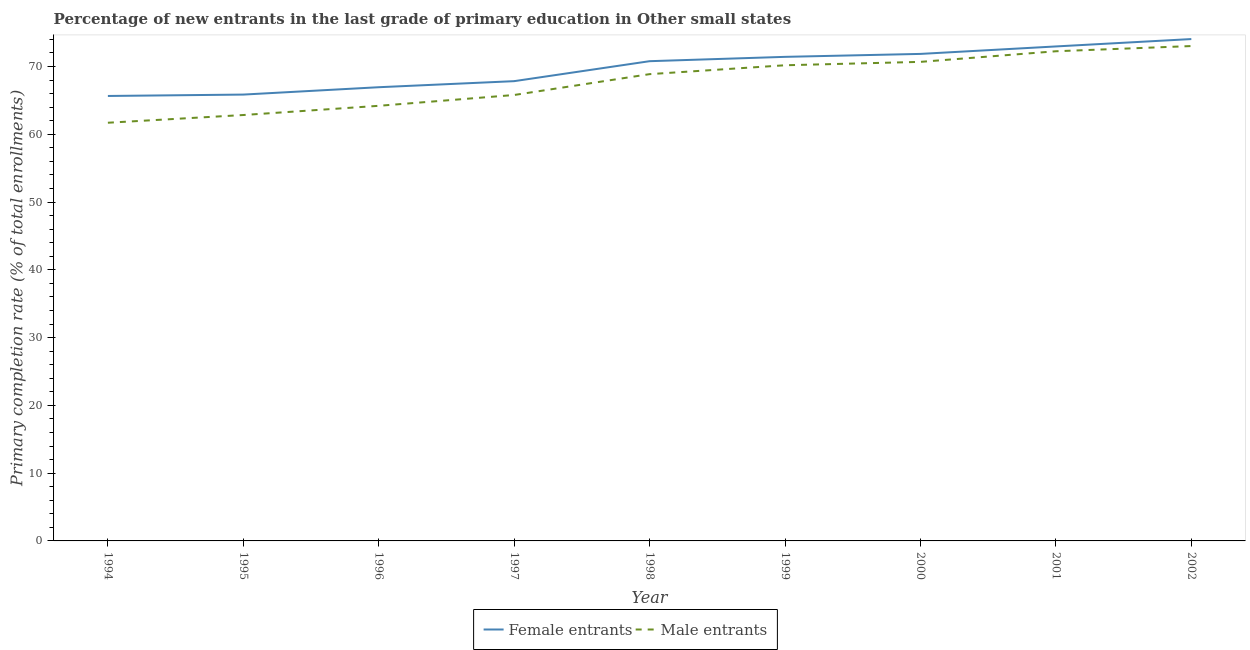How many different coloured lines are there?
Your answer should be compact. 2. Does the line corresponding to primary completion rate of male entrants intersect with the line corresponding to primary completion rate of female entrants?
Give a very brief answer. No. What is the primary completion rate of male entrants in 1995?
Give a very brief answer. 62.84. Across all years, what is the maximum primary completion rate of male entrants?
Provide a short and direct response. 73.02. Across all years, what is the minimum primary completion rate of male entrants?
Provide a succinct answer. 61.7. In which year was the primary completion rate of male entrants minimum?
Your response must be concise. 1994. What is the total primary completion rate of male entrants in the graph?
Offer a very short reply. 609.54. What is the difference between the primary completion rate of female entrants in 1996 and that in 1998?
Make the answer very short. -3.84. What is the difference between the primary completion rate of male entrants in 1999 and the primary completion rate of female entrants in 2001?
Your answer should be compact. -2.78. What is the average primary completion rate of female entrants per year?
Ensure brevity in your answer.  69.71. In the year 1998, what is the difference between the primary completion rate of female entrants and primary completion rate of male entrants?
Offer a very short reply. 1.91. In how many years, is the primary completion rate of male entrants greater than 56 %?
Your response must be concise. 9. What is the ratio of the primary completion rate of female entrants in 1997 to that in 1999?
Offer a very short reply. 0.95. What is the difference between the highest and the second highest primary completion rate of female entrants?
Offer a very short reply. 1.09. What is the difference between the highest and the lowest primary completion rate of male entrants?
Give a very brief answer. 11.32. Does the primary completion rate of male entrants monotonically increase over the years?
Your answer should be compact. Yes. Is the primary completion rate of male entrants strictly greater than the primary completion rate of female entrants over the years?
Provide a succinct answer. No. How many lines are there?
Ensure brevity in your answer.  2. What is the difference between two consecutive major ticks on the Y-axis?
Provide a short and direct response. 10. Does the graph contain any zero values?
Keep it short and to the point. No. How many legend labels are there?
Your answer should be compact. 2. How are the legend labels stacked?
Ensure brevity in your answer.  Horizontal. What is the title of the graph?
Your answer should be very brief. Percentage of new entrants in the last grade of primary education in Other small states. What is the label or title of the X-axis?
Ensure brevity in your answer.  Year. What is the label or title of the Y-axis?
Your answer should be compact. Primary completion rate (% of total enrollments). What is the Primary completion rate (% of total enrollments) in Female entrants in 1994?
Provide a short and direct response. 65.65. What is the Primary completion rate (% of total enrollments) in Male entrants in 1994?
Give a very brief answer. 61.7. What is the Primary completion rate (% of total enrollments) in Female entrants in 1995?
Provide a short and direct response. 65.86. What is the Primary completion rate (% of total enrollments) of Male entrants in 1995?
Provide a succinct answer. 62.84. What is the Primary completion rate (% of total enrollments) of Female entrants in 1996?
Provide a short and direct response. 66.94. What is the Primary completion rate (% of total enrollments) of Male entrants in 1996?
Make the answer very short. 64.2. What is the Primary completion rate (% of total enrollments) of Female entrants in 1997?
Offer a very short reply. 67.84. What is the Primary completion rate (% of total enrollments) of Male entrants in 1997?
Provide a succinct answer. 65.8. What is the Primary completion rate (% of total enrollments) of Female entrants in 1998?
Offer a terse response. 70.78. What is the Primary completion rate (% of total enrollments) of Male entrants in 1998?
Your response must be concise. 68.87. What is the Primary completion rate (% of total enrollments) in Female entrants in 1999?
Your response must be concise. 71.42. What is the Primary completion rate (% of total enrollments) of Male entrants in 1999?
Your answer should be compact. 70.18. What is the Primary completion rate (% of total enrollments) in Female entrants in 2000?
Keep it short and to the point. 71.86. What is the Primary completion rate (% of total enrollments) in Male entrants in 2000?
Your answer should be compact. 70.68. What is the Primary completion rate (% of total enrollments) in Female entrants in 2001?
Offer a very short reply. 72.96. What is the Primary completion rate (% of total enrollments) of Male entrants in 2001?
Give a very brief answer. 72.25. What is the Primary completion rate (% of total enrollments) of Female entrants in 2002?
Give a very brief answer. 74.05. What is the Primary completion rate (% of total enrollments) in Male entrants in 2002?
Provide a short and direct response. 73.02. Across all years, what is the maximum Primary completion rate (% of total enrollments) of Female entrants?
Ensure brevity in your answer.  74.05. Across all years, what is the maximum Primary completion rate (% of total enrollments) in Male entrants?
Make the answer very short. 73.02. Across all years, what is the minimum Primary completion rate (% of total enrollments) of Female entrants?
Give a very brief answer. 65.65. Across all years, what is the minimum Primary completion rate (% of total enrollments) of Male entrants?
Offer a very short reply. 61.7. What is the total Primary completion rate (% of total enrollments) in Female entrants in the graph?
Provide a succinct answer. 627.36. What is the total Primary completion rate (% of total enrollments) in Male entrants in the graph?
Make the answer very short. 609.54. What is the difference between the Primary completion rate (% of total enrollments) in Female entrants in 1994 and that in 1995?
Provide a short and direct response. -0.2. What is the difference between the Primary completion rate (% of total enrollments) in Male entrants in 1994 and that in 1995?
Your response must be concise. -1.14. What is the difference between the Primary completion rate (% of total enrollments) of Female entrants in 1994 and that in 1996?
Keep it short and to the point. -1.29. What is the difference between the Primary completion rate (% of total enrollments) in Male entrants in 1994 and that in 1996?
Your answer should be very brief. -2.5. What is the difference between the Primary completion rate (% of total enrollments) in Female entrants in 1994 and that in 1997?
Make the answer very short. -2.18. What is the difference between the Primary completion rate (% of total enrollments) in Male entrants in 1994 and that in 1997?
Your response must be concise. -4.09. What is the difference between the Primary completion rate (% of total enrollments) in Female entrants in 1994 and that in 1998?
Your answer should be compact. -5.13. What is the difference between the Primary completion rate (% of total enrollments) of Male entrants in 1994 and that in 1998?
Ensure brevity in your answer.  -7.17. What is the difference between the Primary completion rate (% of total enrollments) in Female entrants in 1994 and that in 1999?
Ensure brevity in your answer.  -5.77. What is the difference between the Primary completion rate (% of total enrollments) in Male entrants in 1994 and that in 1999?
Provide a succinct answer. -8.48. What is the difference between the Primary completion rate (% of total enrollments) in Female entrants in 1994 and that in 2000?
Keep it short and to the point. -6.21. What is the difference between the Primary completion rate (% of total enrollments) in Male entrants in 1994 and that in 2000?
Provide a short and direct response. -8.98. What is the difference between the Primary completion rate (% of total enrollments) of Female entrants in 1994 and that in 2001?
Ensure brevity in your answer.  -7.31. What is the difference between the Primary completion rate (% of total enrollments) of Male entrants in 1994 and that in 2001?
Offer a very short reply. -10.55. What is the difference between the Primary completion rate (% of total enrollments) in Female entrants in 1994 and that in 2002?
Make the answer very short. -8.4. What is the difference between the Primary completion rate (% of total enrollments) of Male entrants in 1994 and that in 2002?
Give a very brief answer. -11.32. What is the difference between the Primary completion rate (% of total enrollments) of Female entrants in 1995 and that in 1996?
Offer a terse response. -1.09. What is the difference between the Primary completion rate (% of total enrollments) of Male entrants in 1995 and that in 1996?
Keep it short and to the point. -1.36. What is the difference between the Primary completion rate (% of total enrollments) of Female entrants in 1995 and that in 1997?
Your response must be concise. -1.98. What is the difference between the Primary completion rate (% of total enrollments) of Male entrants in 1995 and that in 1997?
Provide a succinct answer. -2.96. What is the difference between the Primary completion rate (% of total enrollments) of Female entrants in 1995 and that in 1998?
Your answer should be compact. -4.93. What is the difference between the Primary completion rate (% of total enrollments) in Male entrants in 1995 and that in 1998?
Offer a terse response. -6.03. What is the difference between the Primary completion rate (% of total enrollments) of Female entrants in 1995 and that in 1999?
Keep it short and to the point. -5.57. What is the difference between the Primary completion rate (% of total enrollments) in Male entrants in 1995 and that in 1999?
Make the answer very short. -7.34. What is the difference between the Primary completion rate (% of total enrollments) of Female entrants in 1995 and that in 2000?
Provide a short and direct response. -6. What is the difference between the Primary completion rate (% of total enrollments) of Male entrants in 1995 and that in 2000?
Offer a very short reply. -7.84. What is the difference between the Primary completion rate (% of total enrollments) in Female entrants in 1995 and that in 2001?
Offer a very short reply. -7.1. What is the difference between the Primary completion rate (% of total enrollments) in Male entrants in 1995 and that in 2001?
Your answer should be very brief. -9.41. What is the difference between the Primary completion rate (% of total enrollments) in Female entrants in 1995 and that in 2002?
Keep it short and to the point. -8.19. What is the difference between the Primary completion rate (% of total enrollments) of Male entrants in 1995 and that in 2002?
Keep it short and to the point. -10.18. What is the difference between the Primary completion rate (% of total enrollments) of Female entrants in 1996 and that in 1997?
Offer a terse response. -0.89. What is the difference between the Primary completion rate (% of total enrollments) of Male entrants in 1996 and that in 1997?
Make the answer very short. -1.6. What is the difference between the Primary completion rate (% of total enrollments) in Female entrants in 1996 and that in 1998?
Your answer should be compact. -3.84. What is the difference between the Primary completion rate (% of total enrollments) in Male entrants in 1996 and that in 1998?
Give a very brief answer. -4.67. What is the difference between the Primary completion rate (% of total enrollments) of Female entrants in 1996 and that in 1999?
Give a very brief answer. -4.48. What is the difference between the Primary completion rate (% of total enrollments) of Male entrants in 1996 and that in 1999?
Your answer should be compact. -5.98. What is the difference between the Primary completion rate (% of total enrollments) in Female entrants in 1996 and that in 2000?
Offer a terse response. -4.91. What is the difference between the Primary completion rate (% of total enrollments) of Male entrants in 1996 and that in 2000?
Offer a terse response. -6.48. What is the difference between the Primary completion rate (% of total enrollments) of Female entrants in 1996 and that in 2001?
Keep it short and to the point. -6.02. What is the difference between the Primary completion rate (% of total enrollments) of Male entrants in 1996 and that in 2001?
Provide a succinct answer. -8.05. What is the difference between the Primary completion rate (% of total enrollments) of Female entrants in 1996 and that in 2002?
Ensure brevity in your answer.  -7.11. What is the difference between the Primary completion rate (% of total enrollments) in Male entrants in 1996 and that in 2002?
Your answer should be very brief. -8.82. What is the difference between the Primary completion rate (% of total enrollments) of Female entrants in 1997 and that in 1998?
Your answer should be very brief. -2.95. What is the difference between the Primary completion rate (% of total enrollments) in Male entrants in 1997 and that in 1998?
Your answer should be compact. -3.08. What is the difference between the Primary completion rate (% of total enrollments) of Female entrants in 1997 and that in 1999?
Provide a succinct answer. -3.59. What is the difference between the Primary completion rate (% of total enrollments) of Male entrants in 1997 and that in 1999?
Provide a succinct answer. -4.39. What is the difference between the Primary completion rate (% of total enrollments) of Female entrants in 1997 and that in 2000?
Your answer should be very brief. -4.02. What is the difference between the Primary completion rate (% of total enrollments) in Male entrants in 1997 and that in 2000?
Offer a very short reply. -4.89. What is the difference between the Primary completion rate (% of total enrollments) in Female entrants in 1997 and that in 2001?
Provide a succinct answer. -5.12. What is the difference between the Primary completion rate (% of total enrollments) of Male entrants in 1997 and that in 2001?
Make the answer very short. -6.45. What is the difference between the Primary completion rate (% of total enrollments) of Female entrants in 1997 and that in 2002?
Provide a short and direct response. -6.21. What is the difference between the Primary completion rate (% of total enrollments) of Male entrants in 1997 and that in 2002?
Keep it short and to the point. -7.22. What is the difference between the Primary completion rate (% of total enrollments) in Female entrants in 1998 and that in 1999?
Your answer should be compact. -0.64. What is the difference between the Primary completion rate (% of total enrollments) of Male entrants in 1998 and that in 1999?
Offer a very short reply. -1.31. What is the difference between the Primary completion rate (% of total enrollments) in Female entrants in 1998 and that in 2000?
Offer a very short reply. -1.07. What is the difference between the Primary completion rate (% of total enrollments) of Male entrants in 1998 and that in 2000?
Keep it short and to the point. -1.81. What is the difference between the Primary completion rate (% of total enrollments) of Female entrants in 1998 and that in 2001?
Offer a terse response. -2.18. What is the difference between the Primary completion rate (% of total enrollments) of Male entrants in 1998 and that in 2001?
Make the answer very short. -3.38. What is the difference between the Primary completion rate (% of total enrollments) in Female entrants in 1998 and that in 2002?
Provide a short and direct response. -3.26. What is the difference between the Primary completion rate (% of total enrollments) of Male entrants in 1998 and that in 2002?
Offer a very short reply. -4.15. What is the difference between the Primary completion rate (% of total enrollments) in Female entrants in 1999 and that in 2000?
Give a very brief answer. -0.43. What is the difference between the Primary completion rate (% of total enrollments) in Male entrants in 1999 and that in 2000?
Your answer should be very brief. -0.5. What is the difference between the Primary completion rate (% of total enrollments) in Female entrants in 1999 and that in 2001?
Provide a short and direct response. -1.54. What is the difference between the Primary completion rate (% of total enrollments) of Male entrants in 1999 and that in 2001?
Your response must be concise. -2.07. What is the difference between the Primary completion rate (% of total enrollments) in Female entrants in 1999 and that in 2002?
Your response must be concise. -2.63. What is the difference between the Primary completion rate (% of total enrollments) in Male entrants in 1999 and that in 2002?
Make the answer very short. -2.83. What is the difference between the Primary completion rate (% of total enrollments) of Female entrants in 2000 and that in 2001?
Give a very brief answer. -1.1. What is the difference between the Primary completion rate (% of total enrollments) in Male entrants in 2000 and that in 2001?
Your answer should be compact. -1.57. What is the difference between the Primary completion rate (% of total enrollments) of Female entrants in 2000 and that in 2002?
Your response must be concise. -2.19. What is the difference between the Primary completion rate (% of total enrollments) in Male entrants in 2000 and that in 2002?
Offer a terse response. -2.33. What is the difference between the Primary completion rate (% of total enrollments) in Female entrants in 2001 and that in 2002?
Your answer should be very brief. -1.09. What is the difference between the Primary completion rate (% of total enrollments) in Male entrants in 2001 and that in 2002?
Provide a succinct answer. -0.77. What is the difference between the Primary completion rate (% of total enrollments) in Female entrants in 1994 and the Primary completion rate (% of total enrollments) in Male entrants in 1995?
Your answer should be compact. 2.81. What is the difference between the Primary completion rate (% of total enrollments) in Female entrants in 1994 and the Primary completion rate (% of total enrollments) in Male entrants in 1996?
Give a very brief answer. 1.45. What is the difference between the Primary completion rate (% of total enrollments) of Female entrants in 1994 and the Primary completion rate (% of total enrollments) of Male entrants in 1997?
Your answer should be very brief. -0.14. What is the difference between the Primary completion rate (% of total enrollments) in Female entrants in 1994 and the Primary completion rate (% of total enrollments) in Male entrants in 1998?
Give a very brief answer. -3.22. What is the difference between the Primary completion rate (% of total enrollments) of Female entrants in 1994 and the Primary completion rate (% of total enrollments) of Male entrants in 1999?
Ensure brevity in your answer.  -4.53. What is the difference between the Primary completion rate (% of total enrollments) in Female entrants in 1994 and the Primary completion rate (% of total enrollments) in Male entrants in 2000?
Your answer should be compact. -5.03. What is the difference between the Primary completion rate (% of total enrollments) in Female entrants in 1994 and the Primary completion rate (% of total enrollments) in Male entrants in 2001?
Offer a terse response. -6.6. What is the difference between the Primary completion rate (% of total enrollments) of Female entrants in 1994 and the Primary completion rate (% of total enrollments) of Male entrants in 2002?
Your answer should be very brief. -7.36. What is the difference between the Primary completion rate (% of total enrollments) of Female entrants in 1995 and the Primary completion rate (% of total enrollments) of Male entrants in 1996?
Your response must be concise. 1.66. What is the difference between the Primary completion rate (% of total enrollments) of Female entrants in 1995 and the Primary completion rate (% of total enrollments) of Male entrants in 1997?
Ensure brevity in your answer.  0.06. What is the difference between the Primary completion rate (% of total enrollments) of Female entrants in 1995 and the Primary completion rate (% of total enrollments) of Male entrants in 1998?
Provide a short and direct response. -3.01. What is the difference between the Primary completion rate (% of total enrollments) in Female entrants in 1995 and the Primary completion rate (% of total enrollments) in Male entrants in 1999?
Offer a very short reply. -4.33. What is the difference between the Primary completion rate (% of total enrollments) of Female entrants in 1995 and the Primary completion rate (% of total enrollments) of Male entrants in 2000?
Make the answer very short. -4.83. What is the difference between the Primary completion rate (% of total enrollments) in Female entrants in 1995 and the Primary completion rate (% of total enrollments) in Male entrants in 2001?
Your response must be concise. -6.39. What is the difference between the Primary completion rate (% of total enrollments) in Female entrants in 1995 and the Primary completion rate (% of total enrollments) in Male entrants in 2002?
Offer a terse response. -7.16. What is the difference between the Primary completion rate (% of total enrollments) of Female entrants in 1996 and the Primary completion rate (% of total enrollments) of Male entrants in 1997?
Provide a short and direct response. 1.15. What is the difference between the Primary completion rate (% of total enrollments) in Female entrants in 1996 and the Primary completion rate (% of total enrollments) in Male entrants in 1998?
Ensure brevity in your answer.  -1.93. What is the difference between the Primary completion rate (% of total enrollments) of Female entrants in 1996 and the Primary completion rate (% of total enrollments) of Male entrants in 1999?
Keep it short and to the point. -3.24. What is the difference between the Primary completion rate (% of total enrollments) in Female entrants in 1996 and the Primary completion rate (% of total enrollments) in Male entrants in 2000?
Give a very brief answer. -3.74. What is the difference between the Primary completion rate (% of total enrollments) of Female entrants in 1996 and the Primary completion rate (% of total enrollments) of Male entrants in 2001?
Offer a terse response. -5.31. What is the difference between the Primary completion rate (% of total enrollments) of Female entrants in 1996 and the Primary completion rate (% of total enrollments) of Male entrants in 2002?
Provide a succinct answer. -6.07. What is the difference between the Primary completion rate (% of total enrollments) of Female entrants in 1997 and the Primary completion rate (% of total enrollments) of Male entrants in 1998?
Give a very brief answer. -1.03. What is the difference between the Primary completion rate (% of total enrollments) in Female entrants in 1997 and the Primary completion rate (% of total enrollments) in Male entrants in 1999?
Give a very brief answer. -2.34. What is the difference between the Primary completion rate (% of total enrollments) of Female entrants in 1997 and the Primary completion rate (% of total enrollments) of Male entrants in 2000?
Give a very brief answer. -2.85. What is the difference between the Primary completion rate (% of total enrollments) of Female entrants in 1997 and the Primary completion rate (% of total enrollments) of Male entrants in 2001?
Make the answer very short. -4.41. What is the difference between the Primary completion rate (% of total enrollments) of Female entrants in 1997 and the Primary completion rate (% of total enrollments) of Male entrants in 2002?
Make the answer very short. -5.18. What is the difference between the Primary completion rate (% of total enrollments) of Female entrants in 1998 and the Primary completion rate (% of total enrollments) of Male entrants in 1999?
Offer a very short reply. 0.6. What is the difference between the Primary completion rate (% of total enrollments) in Female entrants in 1998 and the Primary completion rate (% of total enrollments) in Male entrants in 2000?
Keep it short and to the point. 0.1. What is the difference between the Primary completion rate (% of total enrollments) in Female entrants in 1998 and the Primary completion rate (% of total enrollments) in Male entrants in 2001?
Your response must be concise. -1.47. What is the difference between the Primary completion rate (% of total enrollments) of Female entrants in 1998 and the Primary completion rate (% of total enrollments) of Male entrants in 2002?
Your response must be concise. -2.23. What is the difference between the Primary completion rate (% of total enrollments) in Female entrants in 1999 and the Primary completion rate (% of total enrollments) in Male entrants in 2000?
Your answer should be compact. 0.74. What is the difference between the Primary completion rate (% of total enrollments) in Female entrants in 1999 and the Primary completion rate (% of total enrollments) in Male entrants in 2001?
Offer a very short reply. -0.83. What is the difference between the Primary completion rate (% of total enrollments) of Female entrants in 1999 and the Primary completion rate (% of total enrollments) of Male entrants in 2002?
Make the answer very short. -1.59. What is the difference between the Primary completion rate (% of total enrollments) in Female entrants in 2000 and the Primary completion rate (% of total enrollments) in Male entrants in 2001?
Provide a succinct answer. -0.39. What is the difference between the Primary completion rate (% of total enrollments) of Female entrants in 2000 and the Primary completion rate (% of total enrollments) of Male entrants in 2002?
Your answer should be very brief. -1.16. What is the difference between the Primary completion rate (% of total enrollments) in Female entrants in 2001 and the Primary completion rate (% of total enrollments) in Male entrants in 2002?
Your answer should be compact. -0.06. What is the average Primary completion rate (% of total enrollments) of Female entrants per year?
Provide a short and direct response. 69.71. What is the average Primary completion rate (% of total enrollments) of Male entrants per year?
Offer a very short reply. 67.73. In the year 1994, what is the difference between the Primary completion rate (% of total enrollments) in Female entrants and Primary completion rate (% of total enrollments) in Male entrants?
Offer a terse response. 3.95. In the year 1995, what is the difference between the Primary completion rate (% of total enrollments) in Female entrants and Primary completion rate (% of total enrollments) in Male entrants?
Give a very brief answer. 3.02. In the year 1996, what is the difference between the Primary completion rate (% of total enrollments) of Female entrants and Primary completion rate (% of total enrollments) of Male entrants?
Keep it short and to the point. 2.74. In the year 1997, what is the difference between the Primary completion rate (% of total enrollments) in Female entrants and Primary completion rate (% of total enrollments) in Male entrants?
Ensure brevity in your answer.  2.04. In the year 1998, what is the difference between the Primary completion rate (% of total enrollments) in Female entrants and Primary completion rate (% of total enrollments) in Male entrants?
Make the answer very short. 1.91. In the year 1999, what is the difference between the Primary completion rate (% of total enrollments) of Female entrants and Primary completion rate (% of total enrollments) of Male entrants?
Give a very brief answer. 1.24. In the year 2000, what is the difference between the Primary completion rate (% of total enrollments) in Female entrants and Primary completion rate (% of total enrollments) in Male entrants?
Make the answer very short. 1.17. In the year 2001, what is the difference between the Primary completion rate (% of total enrollments) of Female entrants and Primary completion rate (% of total enrollments) of Male entrants?
Give a very brief answer. 0.71. In the year 2002, what is the difference between the Primary completion rate (% of total enrollments) in Female entrants and Primary completion rate (% of total enrollments) in Male entrants?
Your answer should be compact. 1.03. What is the ratio of the Primary completion rate (% of total enrollments) in Male entrants in 1994 to that in 1995?
Offer a very short reply. 0.98. What is the ratio of the Primary completion rate (% of total enrollments) in Female entrants in 1994 to that in 1996?
Make the answer very short. 0.98. What is the ratio of the Primary completion rate (% of total enrollments) in Male entrants in 1994 to that in 1996?
Ensure brevity in your answer.  0.96. What is the ratio of the Primary completion rate (% of total enrollments) of Female entrants in 1994 to that in 1997?
Offer a very short reply. 0.97. What is the ratio of the Primary completion rate (% of total enrollments) of Male entrants in 1994 to that in 1997?
Provide a short and direct response. 0.94. What is the ratio of the Primary completion rate (% of total enrollments) in Female entrants in 1994 to that in 1998?
Make the answer very short. 0.93. What is the ratio of the Primary completion rate (% of total enrollments) in Male entrants in 1994 to that in 1998?
Give a very brief answer. 0.9. What is the ratio of the Primary completion rate (% of total enrollments) in Female entrants in 1994 to that in 1999?
Keep it short and to the point. 0.92. What is the ratio of the Primary completion rate (% of total enrollments) of Male entrants in 1994 to that in 1999?
Make the answer very short. 0.88. What is the ratio of the Primary completion rate (% of total enrollments) of Female entrants in 1994 to that in 2000?
Provide a succinct answer. 0.91. What is the ratio of the Primary completion rate (% of total enrollments) in Male entrants in 1994 to that in 2000?
Provide a succinct answer. 0.87. What is the ratio of the Primary completion rate (% of total enrollments) in Female entrants in 1994 to that in 2001?
Your answer should be very brief. 0.9. What is the ratio of the Primary completion rate (% of total enrollments) of Male entrants in 1994 to that in 2001?
Your answer should be compact. 0.85. What is the ratio of the Primary completion rate (% of total enrollments) in Female entrants in 1994 to that in 2002?
Your answer should be compact. 0.89. What is the ratio of the Primary completion rate (% of total enrollments) in Male entrants in 1994 to that in 2002?
Give a very brief answer. 0.84. What is the ratio of the Primary completion rate (% of total enrollments) in Female entrants in 1995 to that in 1996?
Provide a succinct answer. 0.98. What is the ratio of the Primary completion rate (% of total enrollments) of Male entrants in 1995 to that in 1996?
Keep it short and to the point. 0.98. What is the ratio of the Primary completion rate (% of total enrollments) of Female entrants in 1995 to that in 1997?
Provide a succinct answer. 0.97. What is the ratio of the Primary completion rate (% of total enrollments) in Male entrants in 1995 to that in 1997?
Your answer should be compact. 0.96. What is the ratio of the Primary completion rate (% of total enrollments) of Female entrants in 1995 to that in 1998?
Provide a short and direct response. 0.93. What is the ratio of the Primary completion rate (% of total enrollments) of Male entrants in 1995 to that in 1998?
Provide a succinct answer. 0.91. What is the ratio of the Primary completion rate (% of total enrollments) of Female entrants in 1995 to that in 1999?
Offer a very short reply. 0.92. What is the ratio of the Primary completion rate (% of total enrollments) in Male entrants in 1995 to that in 1999?
Your answer should be very brief. 0.9. What is the ratio of the Primary completion rate (% of total enrollments) in Female entrants in 1995 to that in 2000?
Offer a terse response. 0.92. What is the ratio of the Primary completion rate (% of total enrollments) of Male entrants in 1995 to that in 2000?
Offer a very short reply. 0.89. What is the ratio of the Primary completion rate (% of total enrollments) of Female entrants in 1995 to that in 2001?
Provide a short and direct response. 0.9. What is the ratio of the Primary completion rate (% of total enrollments) of Male entrants in 1995 to that in 2001?
Offer a terse response. 0.87. What is the ratio of the Primary completion rate (% of total enrollments) of Female entrants in 1995 to that in 2002?
Provide a short and direct response. 0.89. What is the ratio of the Primary completion rate (% of total enrollments) in Male entrants in 1995 to that in 2002?
Your response must be concise. 0.86. What is the ratio of the Primary completion rate (% of total enrollments) in Female entrants in 1996 to that in 1997?
Offer a terse response. 0.99. What is the ratio of the Primary completion rate (% of total enrollments) in Male entrants in 1996 to that in 1997?
Provide a short and direct response. 0.98. What is the ratio of the Primary completion rate (% of total enrollments) of Female entrants in 1996 to that in 1998?
Your answer should be very brief. 0.95. What is the ratio of the Primary completion rate (% of total enrollments) in Male entrants in 1996 to that in 1998?
Provide a short and direct response. 0.93. What is the ratio of the Primary completion rate (% of total enrollments) in Female entrants in 1996 to that in 1999?
Ensure brevity in your answer.  0.94. What is the ratio of the Primary completion rate (% of total enrollments) in Male entrants in 1996 to that in 1999?
Your answer should be very brief. 0.91. What is the ratio of the Primary completion rate (% of total enrollments) of Female entrants in 1996 to that in 2000?
Keep it short and to the point. 0.93. What is the ratio of the Primary completion rate (% of total enrollments) of Male entrants in 1996 to that in 2000?
Make the answer very short. 0.91. What is the ratio of the Primary completion rate (% of total enrollments) of Female entrants in 1996 to that in 2001?
Keep it short and to the point. 0.92. What is the ratio of the Primary completion rate (% of total enrollments) in Male entrants in 1996 to that in 2001?
Offer a terse response. 0.89. What is the ratio of the Primary completion rate (% of total enrollments) of Female entrants in 1996 to that in 2002?
Provide a short and direct response. 0.9. What is the ratio of the Primary completion rate (% of total enrollments) in Male entrants in 1996 to that in 2002?
Keep it short and to the point. 0.88. What is the ratio of the Primary completion rate (% of total enrollments) of Female entrants in 1997 to that in 1998?
Your answer should be very brief. 0.96. What is the ratio of the Primary completion rate (% of total enrollments) of Male entrants in 1997 to that in 1998?
Your answer should be very brief. 0.96. What is the ratio of the Primary completion rate (% of total enrollments) of Female entrants in 1997 to that in 1999?
Provide a succinct answer. 0.95. What is the ratio of the Primary completion rate (% of total enrollments) in Female entrants in 1997 to that in 2000?
Offer a terse response. 0.94. What is the ratio of the Primary completion rate (% of total enrollments) of Male entrants in 1997 to that in 2000?
Your answer should be very brief. 0.93. What is the ratio of the Primary completion rate (% of total enrollments) of Female entrants in 1997 to that in 2001?
Your response must be concise. 0.93. What is the ratio of the Primary completion rate (% of total enrollments) of Male entrants in 1997 to that in 2001?
Give a very brief answer. 0.91. What is the ratio of the Primary completion rate (% of total enrollments) in Female entrants in 1997 to that in 2002?
Your answer should be very brief. 0.92. What is the ratio of the Primary completion rate (% of total enrollments) in Male entrants in 1997 to that in 2002?
Ensure brevity in your answer.  0.9. What is the ratio of the Primary completion rate (% of total enrollments) of Male entrants in 1998 to that in 1999?
Provide a succinct answer. 0.98. What is the ratio of the Primary completion rate (% of total enrollments) in Female entrants in 1998 to that in 2000?
Make the answer very short. 0.99. What is the ratio of the Primary completion rate (% of total enrollments) of Male entrants in 1998 to that in 2000?
Make the answer very short. 0.97. What is the ratio of the Primary completion rate (% of total enrollments) in Female entrants in 1998 to that in 2001?
Keep it short and to the point. 0.97. What is the ratio of the Primary completion rate (% of total enrollments) in Male entrants in 1998 to that in 2001?
Provide a short and direct response. 0.95. What is the ratio of the Primary completion rate (% of total enrollments) in Female entrants in 1998 to that in 2002?
Offer a terse response. 0.96. What is the ratio of the Primary completion rate (% of total enrollments) in Male entrants in 1998 to that in 2002?
Your response must be concise. 0.94. What is the ratio of the Primary completion rate (% of total enrollments) in Female entrants in 1999 to that in 2000?
Your answer should be very brief. 0.99. What is the ratio of the Primary completion rate (% of total enrollments) in Male entrants in 1999 to that in 2000?
Provide a short and direct response. 0.99. What is the ratio of the Primary completion rate (% of total enrollments) of Female entrants in 1999 to that in 2001?
Provide a succinct answer. 0.98. What is the ratio of the Primary completion rate (% of total enrollments) of Male entrants in 1999 to that in 2001?
Your answer should be compact. 0.97. What is the ratio of the Primary completion rate (% of total enrollments) in Female entrants in 1999 to that in 2002?
Keep it short and to the point. 0.96. What is the ratio of the Primary completion rate (% of total enrollments) in Male entrants in 1999 to that in 2002?
Provide a short and direct response. 0.96. What is the ratio of the Primary completion rate (% of total enrollments) of Female entrants in 2000 to that in 2001?
Your answer should be compact. 0.98. What is the ratio of the Primary completion rate (% of total enrollments) of Male entrants in 2000 to that in 2001?
Provide a short and direct response. 0.98. What is the ratio of the Primary completion rate (% of total enrollments) of Female entrants in 2000 to that in 2002?
Keep it short and to the point. 0.97. What is the ratio of the Primary completion rate (% of total enrollments) in Female entrants in 2001 to that in 2002?
Provide a short and direct response. 0.99. What is the ratio of the Primary completion rate (% of total enrollments) of Male entrants in 2001 to that in 2002?
Provide a short and direct response. 0.99. What is the difference between the highest and the second highest Primary completion rate (% of total enrollments) of Female entrants?
Offer a terse response. 1.09. What is the difference between the highest and the second highest Primary completion rate (% of total enrollments) of Male entrants?
Make the answer very short. 0.77. What is the difference between the highest and the lowest Primary completion rate (% of total enrollments) in Female entrants?
Provide a succinct answer. 8.4. What is the difference between the highest and the lowest Primary completion rate (% of total enrollments) in Male entrants?
Make the answer very short. 11.32. 